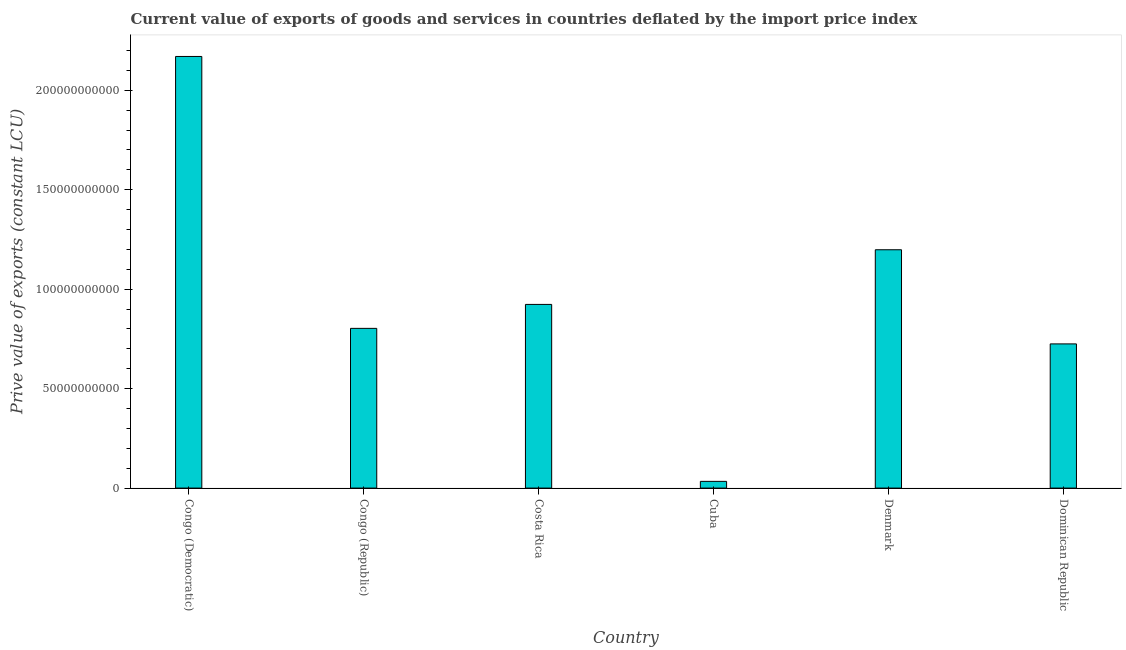What is the title of the graph?
Ensure brevity in your answer.  Current value of exports of goods and services in countries deflated by the import price index. What is the label or title of the Y-axis?
Provide a succinct answer. Prive value of exports (constant LCU). What is the price value of exports in Denmark?
Offer a terse response. 1.20e+11. Across all countries, what is the maximum price value of exports?
Provide a succinct answer. 2.17e+11. Across all countries, what is the minimum price value of exports?
Your answer should be very brief. 3.38e+09. In which country was the price value of exports maximum?
Make the answer very short. Congo (Democratic). In which country was the price value of exports minimum?
Offer a very short reply. Cuba. What is the sum of the price value of exports?
Offer a terse response. 5.85e+11. What is the difference between the price value of exports in Congo (Republic) and Costa Rica?
Offer a terse response. -1.20e+1. What is the average price value of exports per country?
Ensure brevity in your answer.  9.76e+1. What is the median price value of exports?
Give a very brief answer. 8.63e+1. In how many countries, is the price value of exports greater than 210000000000 LCU?
Provide a short and direct response. 1. What is the ratio of the price value of exports in Denmark to that in Dominican Republic?
Provide a short and direct response. 1.65. Is the price value of exports in Costa Rica less than that in Dominican Republic?
Provide a short and direct response. No. Is the difference between the price value of exports in Congo (Republic) and Denmark greater than the difference between any two countries?
Your answer should be compact. No. What is the difference between the highest and the second highest price value of exports?
Your answer should be compact. 9.72e+1. Is the sum of the price value of exports in Cuba and Denmark greater than the maximum price value of exports across all countries?
Offer a terse response. No. What is the difference between the highest and the lowest price value of exports?
Provide a succinct answer. 2.14e+11. How many bars are there?
Your response must be concise. 6. Are all the bars in the graph horizontal?
Keep it short and to the point. No. What is the difference between two consecutive major ticks on the Y-axis?
Ensure brevity in your answer.  5.00e+1. Are the values on the major ticks of Y-axis written in scientific E-notation?
Provide a succinct answer. No. What is the Prive value of exports (constant LCU) in Congo (Democratic)?
Keep it short and to the point. 2.17e+11. What is the Prive value of exports (constant LCU) in Congo (Republic)?
Offer a very short reply. 8.03e+1. What is the Prive value of exports (constant LCU) in Costa Rica?
Make the answer very short. 9.23e+1. What is the Prive value of exports (constant LCU) of Cuba?
Offer a terse response. 3.38e+09. What is the Prive value of exports (constant LCU) of Denmark?
Make the answer very short. 1.20e+11. What is the Prive value of exports (constant LCU) of Dominican Republic?
Your answer should be compact. 7.25e+1. What is the difference between the Prive value of exports (constant LCU) in Congo (Democratic) and Congo (Republic)?
Your answer should be compact. 1.37e+11. What is the difference between the Prive value of exports (constant LCU) in Congo (Democratic) and Costa Rica?
Offer a very short reply. 1.25e+11. What is the difference between the Prive value of exports (constant LCU) in Congo (Democratic) and Cuba?
Provide a short and direct response. 2.14e+11. What is the difference between the Prive value of exports (constant LCU) in Congo (Democratic) and Denmark?
Provide a short and direct response. 9.72e+1. What is the difference between the Prive value of exports (constant LCU) in Congo (Democratic) and Dominican Republic?
Your answer should be compact. 1.45e+11. What is the difference between the Prive value of exports (constant LCU) in Congo (Republic) and Costa Rica?
Make the answer very short. -1.20e+1. What is the difference between the Prive value of exports (constant LCU) in Congo (Republic) and Cuba?
Provide a succinct answer. 7.69e+1. What is the difference between the Prive value of exports (constant LCU) in Congo (Republic) and Denmark?
Ensure brevity in your answer.  -3.95e+1. What is the difference between the Prive value of exports (constant LCU) in Congo (Republic) and Dominican Republic?
Provide a short and direct response. 7.81e+09. What is the difference between the Prive value of exports (constant LCU) in Costa Rica and Cuba?
Your answer should be compact. 8.90e+1. What is the difference between the Prive value of exports (constant LCU) in Costa Rica and Denmark?
Ensure brevity in your answer.  -2.75e+1. What is the difference between the Prive value of exports (constant LCU) in Costa Rica and Dominican Republic?
Provide a short and direct response. 1.99e+1. What is the difference between the Prive value of exports (constant LCU) in Cuba and Denmark?
Ensure brevity in your answer.  -1.16e+11. What is the difference between the Prive value of exports (constant LCU) in Cuba and Dominican Republic?
Provide a short and direct response. -6.91e+1. What is the difference between the Prive value of exports (constant LCU) in Denmark and Dominican Republic?
Offer a very short reply. 4.73e+1. What is the ratio of the Prive value of exports (constant LCU) in Congo (Democratic) to that in Congo (Republic)?
Offer a terse response. 2.7. What is the ratio of the Prive value of exports (constant LCU) in Congo (Democratic) to that in Costa Rica?
Your response must be concise. 2.35. What is the ratio of the Prive value of exports (constant LCU) in Congo (Democratic) to that in Cuba?
Provide a succinct answer. 64.26. What is the ratio of the Prive value of exports (constant LCU) in Congo (Democratic) to that in Denmark?
Provide a succinct answer. 1.81. What is the ratio of the Prive value of exports (constant LCU) in Congo (Democratic) to that in Dominican Republic?
Give a very brief answer. 2.99. What is the ratio of the Prive value of exports (constant LCU) in Congo (Republic) to that in Costa Rica?
Your response must be concise. 0.87. What is the ratio of the Prive value of exports (constant LCU) in Congo (Republic) to that in Cuba?
Your answer should be very brief. 23.78. What is the ratio of the Prive value of exports (constant LCU) in Congo (Republic) to that in Denmark?
Keep it short and to the point. 0.67. What is the ratio of the Prive value of exports (constant LCU) in Congo (Republic) to that in Dominican Republic?
Give a very brief answer. 1.11. What is the ratio of the Prive value of exports (constant LCU) in Costa Rica to that in Cuba?
Provide a short and direct response. 27.35. What is the ratio of the Prive value of exports (constant LCU) in Costa Rica to that in Denmark?
Your response must be concise. 0.77. What is the ratio of the Prive value of exports (constant LCU) in Costa Rica to that in Dominican Republic?
Provide a short and direct response. 1.27. What is the ratio of the Prive value of exports (constant LCU) in Cuba to that in Denmark?
Ensure brevity in your answer.  0.03. What is the ratio of the Prive value of exports (constant LCU) in Cuba to that in Dominican Republic?
Make the answer very short. 0.05. What is the ratio of the Prive value of exports (constant LCU) in Denmark to that in Dominican Republic?
Offer a very short reply. 1.65. 